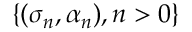<formula> <loc_0><loc_0><loc_500><loc_500>\{ ( \sigma _ { n } , \alpha _ { n } ) , n > 0 \}</formula> 